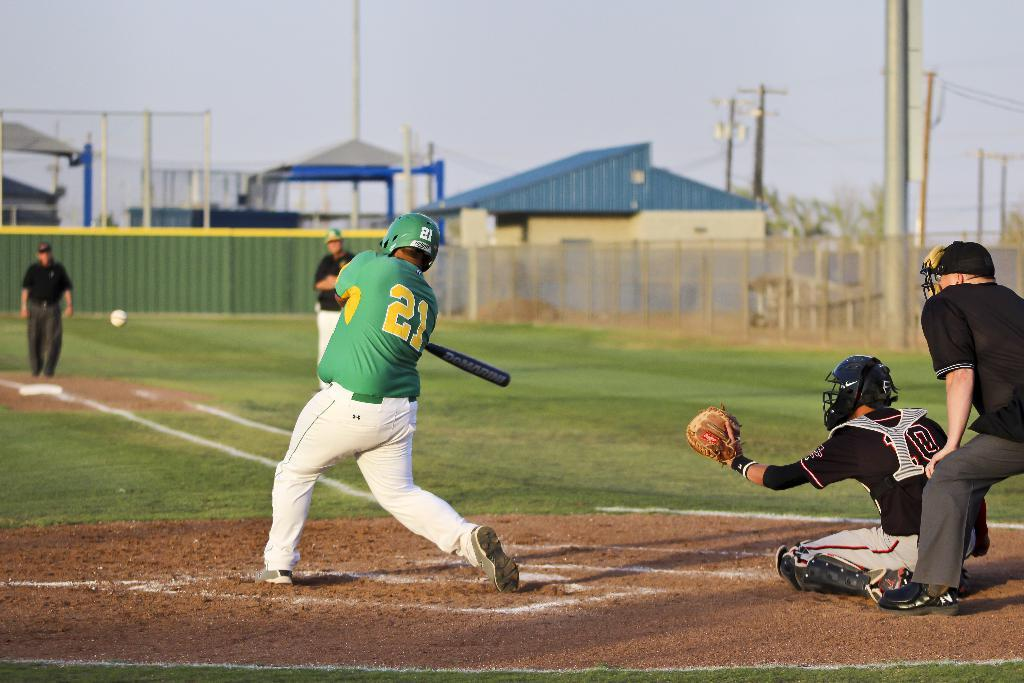<image>
Provide a brief description of the given image. The player 21 is about to hit the ball with the bat. 